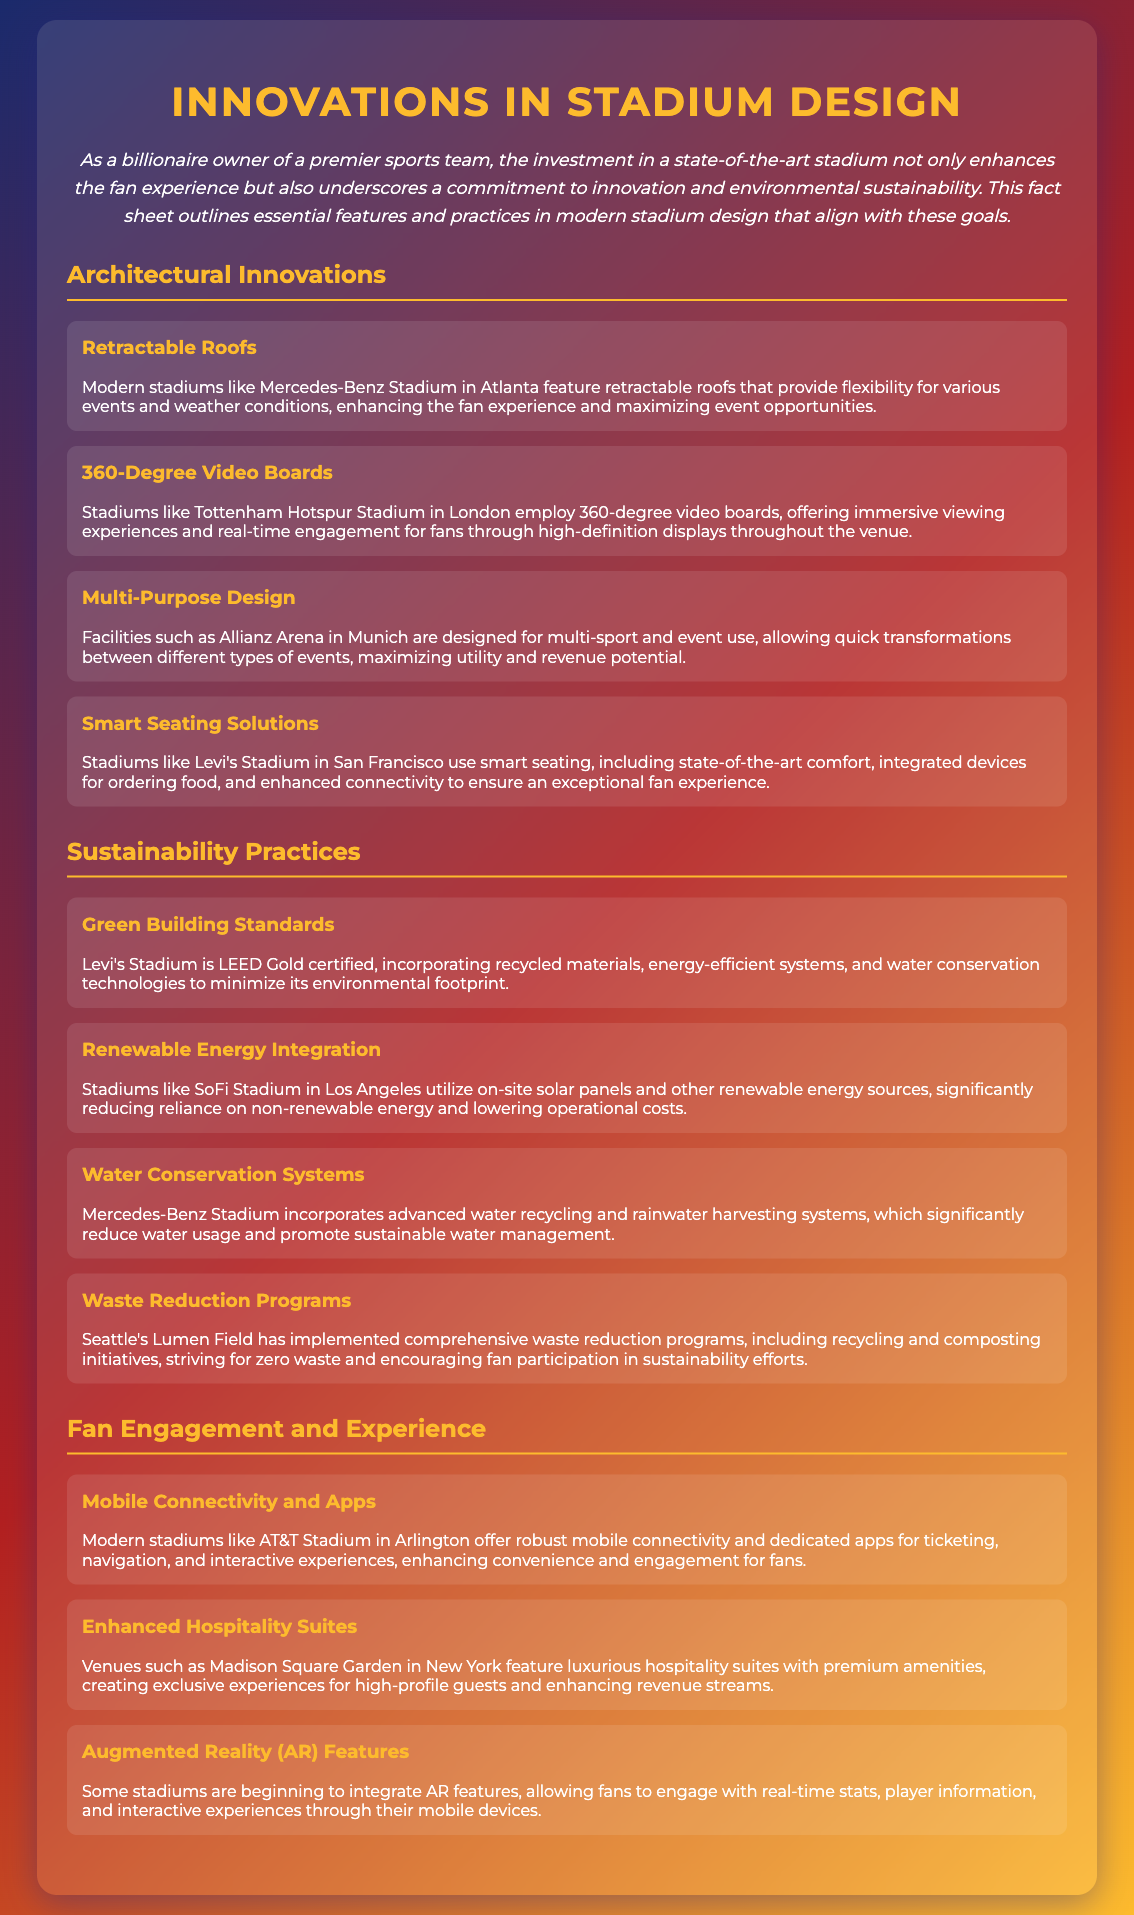what architectural feature is used for flexibility? Retractable roofs allow flexibility for various events and weather conditions, enhancing the fan experience.
Answer: Retractable roofs which stadium has 360-degree video boards? Tottenham Hotspur Stadium in London employs 360-degree video boards for immersive viewing experiences.
Answer: Tottenham Hotspur Stadium what sustainability certification does Levi's Stadium have? Levi's Stadium is LEED Gold certified, incorporating recycled materials and energy-efficient systems.
Answer: LEED Gold which stadium utilizes on-site solar panels? SoFi Stadium in Los Angeles utilizes on-site solar panels to reduce reliance on non-renewable energy.
Answer: SoFi Stadium what kind of systems does Mercedes-Benz Stadium use for water management? Advanced water recycling and rainwater harvesting systems significantly reduce water usage.
Answer: Water recycling and rainwater harvesting systems what is a key benefit of mobile connectivity in modern stadiums? Mobile connectivity enhances convenience and engagement for fans through ticketing and navigation.
Answer: Convenience and engagement what feature creates exclusive experiences for high-profile guests? Enhanced hospitality suites with premium amenities create exclusive experiences.
Answer: Hospitality suites which waste reduction programs strive for zero waste? Comprehensive waste reduction programs at Lumen Field strive for zero waste and encourage fan participation.
Answer: Lumen Field 